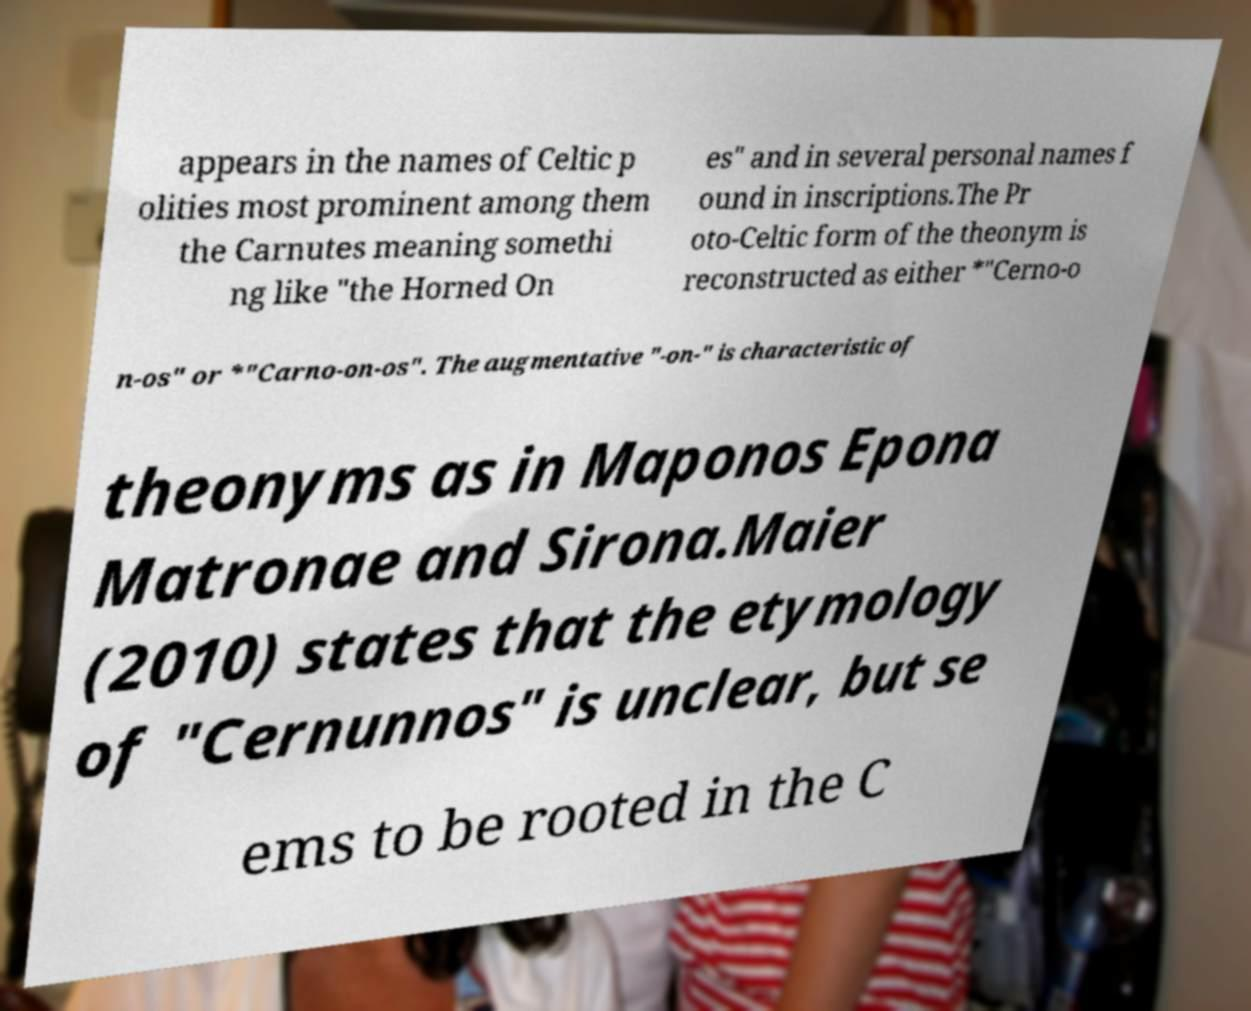Could you assist in decoding the text presented in this image and type it out clearly? appears in the names of Celtic p olities most prominent among them the Carnutes meaning somethi ng like "the Horned On es" and in several personal names f ound in inscriptions.The Pr oto-Celtic form of the theonym is reconstructed as either *"Cerno-o n-os" or *"Carno-on-os". The augmentative "-on-" is characteristic of theonyms as in Maponos Epona Matronae and Sirona.Maier (2010) states that the etymology of "Cernunnos" is unclear, but se ems to be rooted in the C 